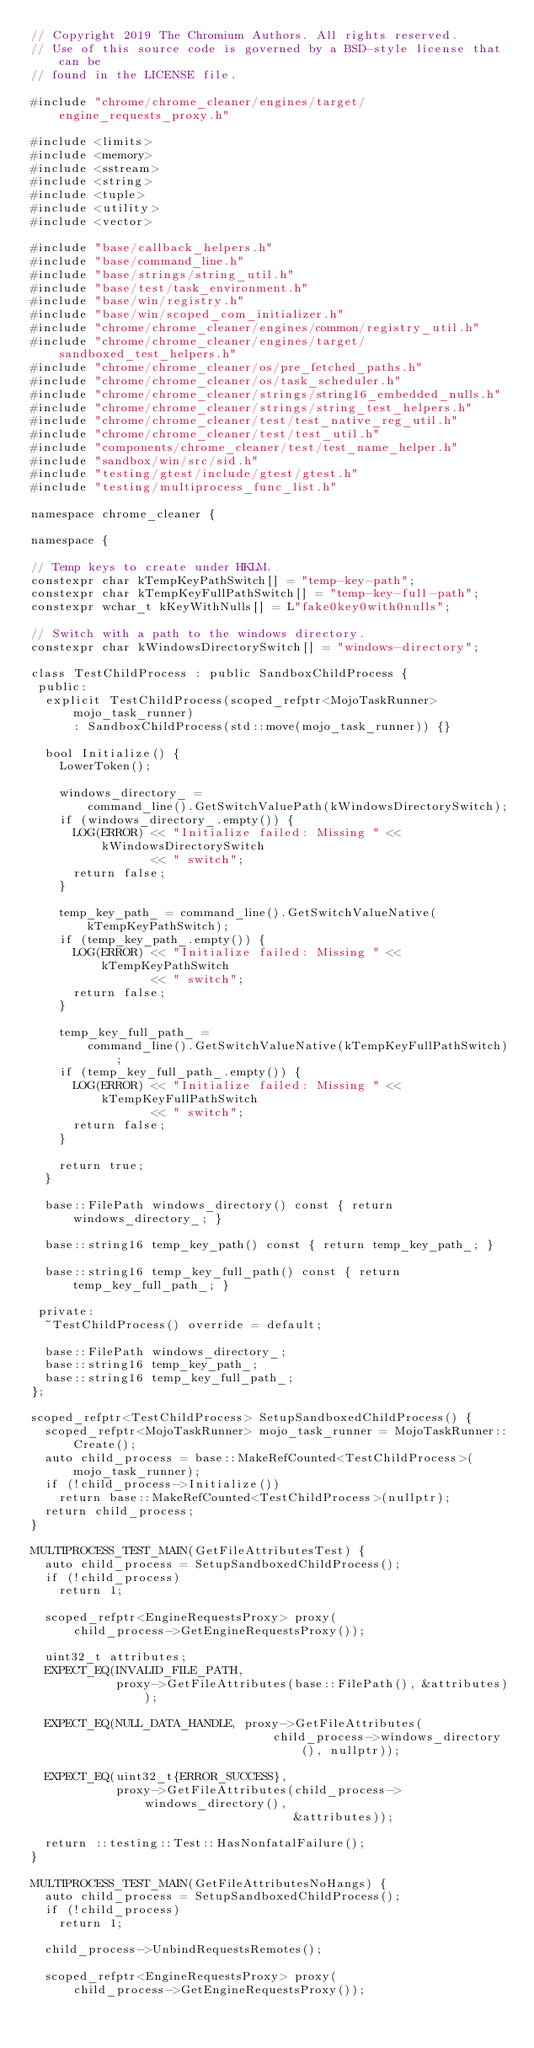Convert code to text. <code><loc_0><loc_0><loc_500><loc_500><_C++_>// Copyright 2019 The Chromium Authors. All rights reserved.
// Use of this source code is governed by a BSD-style license that can be
// found in the LICENSE file.

#include "chrome/chrome_cleaner/engines/target/engine_requests_proxy.h"

#include <limits>
#include <memory>
#include <sstream>
#include <string>
#include <tuple>
#include <utility>
#include <vector>

#include "base/callback_helpers.h"
#include "base/command_line.h"
#include "base/strings/string_util.h"
#include "base/test/task_environment.h"
#include "base/win/registry.h"
#include "base/win/scoped_com_initializer.h"
#include "chrome/chrome_cleaner/engines/common/registry_util.h"
#include "chrome/chrome_cleaner/engines/target/sandboxed_test_helpers.h"
#include "chrome/chrome_cleaner/os/pre_fetched_paths.h"
#include "chrome/chrome_cleaner/os/task_scheduler.h"
#include "chrome/chrome_cleaner/strings/string16_embedded_nulls.h"
#include "chrome/chrome_cleaner/strings/string_test_helpers.h"
#include "chrome/chrome_cleaner/test/test_native_reg_util.h"
#include "chrome/chrome_cleaner/test/test_util.h"
#include "components/chrome_cleaner/test/test_name_helper.h"
#include "sandbox/win/src/sid.h"
#include "testing/gtest/include/gtest/gtest.h"
#include "testing/multiprocess_func_list.h"

namespace chrome_cleaner {

namespace {

// Temp keys to create under HKLM.
constexpr char kTempKeyPathSwitch[] = "temp-key-path";
constexpr char kTempKeyFullPathSwitch[] = "temp-key-full-path";
constexpr wchar_t kKeyWithNulls[] = L"fake0key0with0nulls";

// Switch with a path to the windows directory.
constexpr char kWindowsDirectorySwitch[] = "windows-directory";

class TestChildProcess : public SandboxChildProcess {
 public:
  explicit TestChildProcess(scoped_refptr<MojoTaskRunner> mojo_task_runner)
      : SandboxChildProcess(std::move(mojo_task_runner)) {}

  bool Initialize() {
    LowerToken();

    windows_directory_ =
        command_line().GetSwitchValuePath(kWindowsDirectorySwitch);
    if (windows_directory_.empty()) {
      LOG(ERROR) << "Initialize failed: Missing " << kWindowsDirectorySwitch
                 << " switch";
      return false;
    }

    temp_key_path_ = command_line().GetSwitchValueNative(kTempKeyPathSwitch);
    if (temp_key_path_.empty()) {
      LOG(ERROR) << "Initialize failed: Missing " << kTempKeyPathSwitch
                 << " switch";
      return false;
    }

    temp_key_full_path_ =
        command_line().GetSwitchValueNative(kTempKeyFullPathSwitch);
    if (temp_key_full_path_.empty()) {
      LOG(ERROR) << "Initialize failed: Missing " << kTempKeyFullPathSwitch
                 << " switch";
      return false;
    }

    return true;
  }

  base::FilePath windows_directory() const { return windows_directory_; }

  base::string16 temp_key_path() const { return temp_key_path_; }

  base::string16 temp_key_full_path() const { return temp_key_full_path_; }

 private:
  ~TestChildProcess() override = default;

  base::FilePath windows_directory_;
  base::string16 temp_key_path_;
  base::string16 temp_key_full_path_;
};

scoped_refptr<TestChildProcess> SetupSandboxedChildProcess() {
  scoped_refptr<MojoTaskRunner> mojo_task_runner = MojoTaskRunner::Create();
  auto child_process = base::MakeRefCounted<TestChildProcess>(mojo_task_runner);
  if (!child_process->Initialize())
    return base::MakeRefCounted<TestChildProcess>(nullptr);
  return child_process;
}

MULTIPROCESS_TEST_MAIN(GetFileAttributesTest) {
  auto child_process = SetupSandboxedChildProcess();
  if (!child_process)
    return 1;

  scoped_refptr<EngineRequestsProxy> proxy(
      child_process->GetEngineRequestsProxy());

  uint32_t attributes;
  EXPECT_EQ(INVALID_FILE_PATH,
            proxy->GetFileAttributes(base::FilePath(), &attributes));

  EXPECT_EQ(NULL_DATA_HANDLE, proxy->GetFileAttributes(
                                  child_process->windows_directory(), nullptr));

  EXPECT_EQ(uint32_t{ERROR_SUCCESS},
            proxy->GetFileAttributes(child_process->windows_directory(),
                                     &attributes));

  return ::testing::Test::HasNonfatalFailure();
}

MULTIPROCESS_TEST_MAIN(GetFileAttributesNoHangs) {
  auto child_process = SetupSandboxedChildProcess();
  if (!child_process)
    return 1;

  child_process->UnbindRequestsRemotes();

  scoped_refptr<EngineRequestsProxy> proxy(
      child_process->GetEngineRequestsProxy());
</code> 